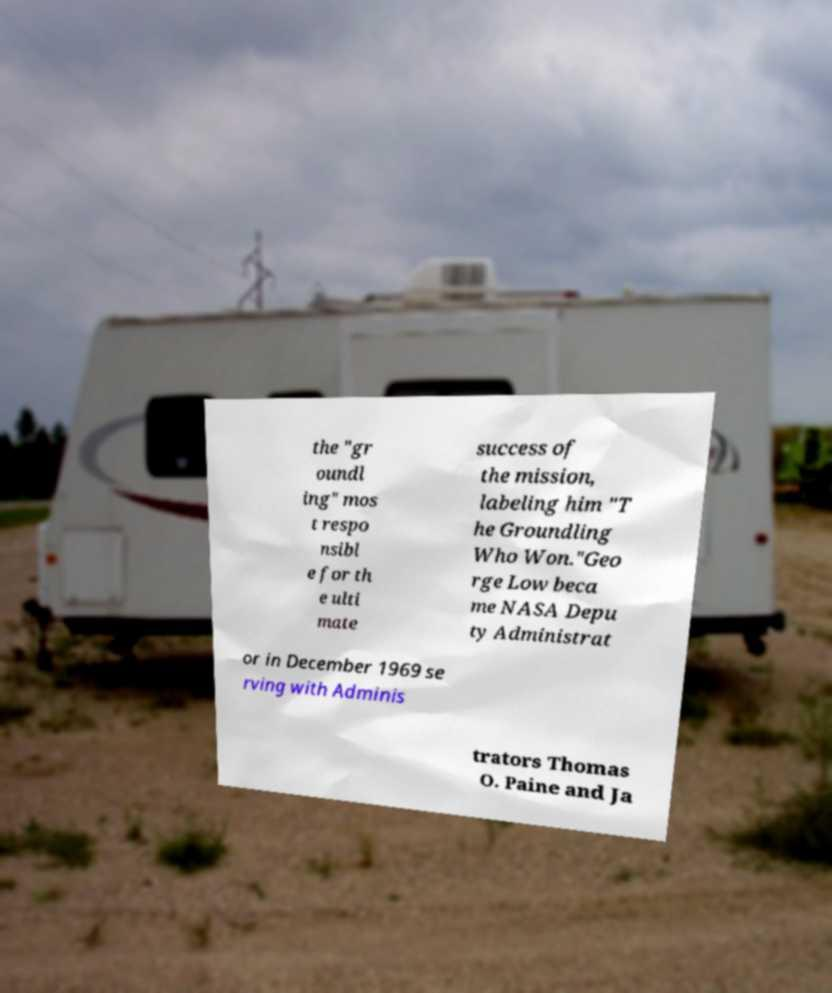Please identify and transcribe the text found in this image. the "gr oundl ing" mos t respo nsibl e for th e ulti mate success of the mission, labeling him "T he Groundling Who Won."Geo rge Low beca me NASA Depu ty Administrat or in December 1969 se rving with Adminis trators Thomas O. Paine and Ja 